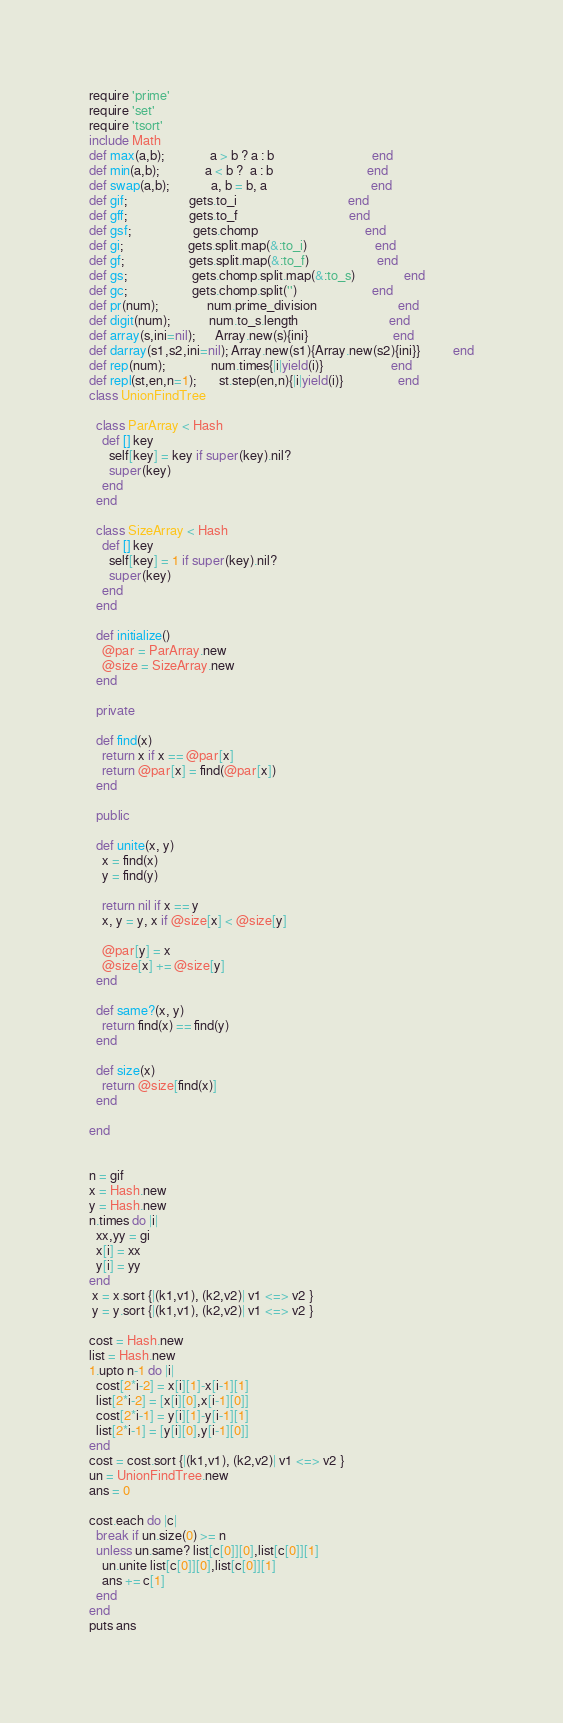<code> <loc_0><loc_0><loc_500><loc_500><_Ruby_>require 'prime'
require 'set'
require 'tsort'
include Math
def max(a,b);              a > b ? a : b                              end
def min(a,b);              a < b ?  a : b                             end
def swap(a,b);             a, b = b, a                                end
def gif;                   gets.to_i                                  end
def gff;                   gets.to_f                                  end
def gsf;                   gets.chomp                                 end
def gi;                    gets.split.map(&:to_i)                     end
def gf;                    gets.split.map(&:to_f)                     end
def gs;                    gets.chomp.split.map(&:to_s)               end
def gc;                    gets.chomp.split('')                       end
def pr(num);               num.prime_division                         end
def digit(num);            num.to_s.length                            end
def array(s,ini=nil);      Array.new(s){ini}                          end
def darray(s1,s2,ini=nil); Array.new(s1){Array.new(s2){ini}}          end
def rep(num);              num.times{|i|yield(i)}                     end
def repl(st,en,n=1);       st.step(en,n){|i|yield(i)}                 end
class UnionFindTree

  class ParArray < Hash
    def [] key
      self[key] = key if super(key).nil?
      super(key)
    end
  end

  class SizeArray < Hash
    def [] key
      self[key] = 1 if super(key).nil?
      super(key)
    end
  end

  def initialize()
    @par = ParArray.new
    @size = SizeArray.new
  end

  private

  def find(x)
    return x if x == @par[x]
    return @par[x] = find(@par[x])
  end

  public

  def unite(x, y)
    x = find(x)
    y = find(y)

    return nil if x == y
    x, y = y, x if @size[x] < @size[y]

    @par[y] = x
    @size[x] += @size[y]
  end

  def same?(x, y)
    return find(x) == find(y)
  end

  def size(x)
    return @size[find(x)]
  end

end


n = gif
x = Hash.new
y = Hash.new
n.times do |i|
  xx,yy = gi
  x[i] = xx
  y[i] = yy
end
 x = x.sort {|(k1,v1), (k2,v2)| v1 <=> v2 }
 y = y.sort {|(k1,v1), (k2,v2)| v1 <=> v2 }

cost = Hash.new
list = Hash.new
1.upto n-1 do |i|
  cost[2*i-2] = x[i][1]-x[i-1][1]
  list[2*i-2] = [x[i][0],x[i-1][0]]
  cost[2*i-1] = y[i][1]-y[i-1][1]
  list[2*i-1] = [y[i][0],y[i-1][0]]
end
cost = cost.sort {|(k1,v1), (k2,v2)| v1 <=> v2 }
un = UnionFindTree.new
ans = 0

cost.each do |c|
  break if un.size(0) >= n
  unless un.same? list[c[0]][0],list[c[0]][1]
    un.unite list[c[0]][0],list[c[0]][1]
    ans += c[1]
  end
end
puts ans
</code> 